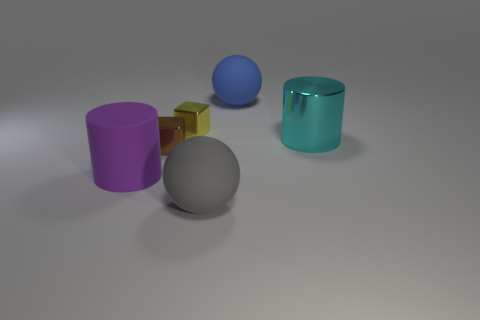Add 2 brown metal balls. How many objects exist? 8 Subtract all cubes. How many objects are left? 4 Add 4 metal blocks. How many metal blocks are left? 6 Add 5 spheres. How many spheres exist? 7 Subtract 0 blue blocks. How many objects are left? 6 Subtract 1 balls. How many balls are left? 1 Subtract all brown cubes. Subtract all brown cylinders. How many cubes are left? 1 Subtract all yellow cylinders. How many cyan balls are left? 0 Subtract all cyan things. Subtract all big matte things. How many objects are left? 2 